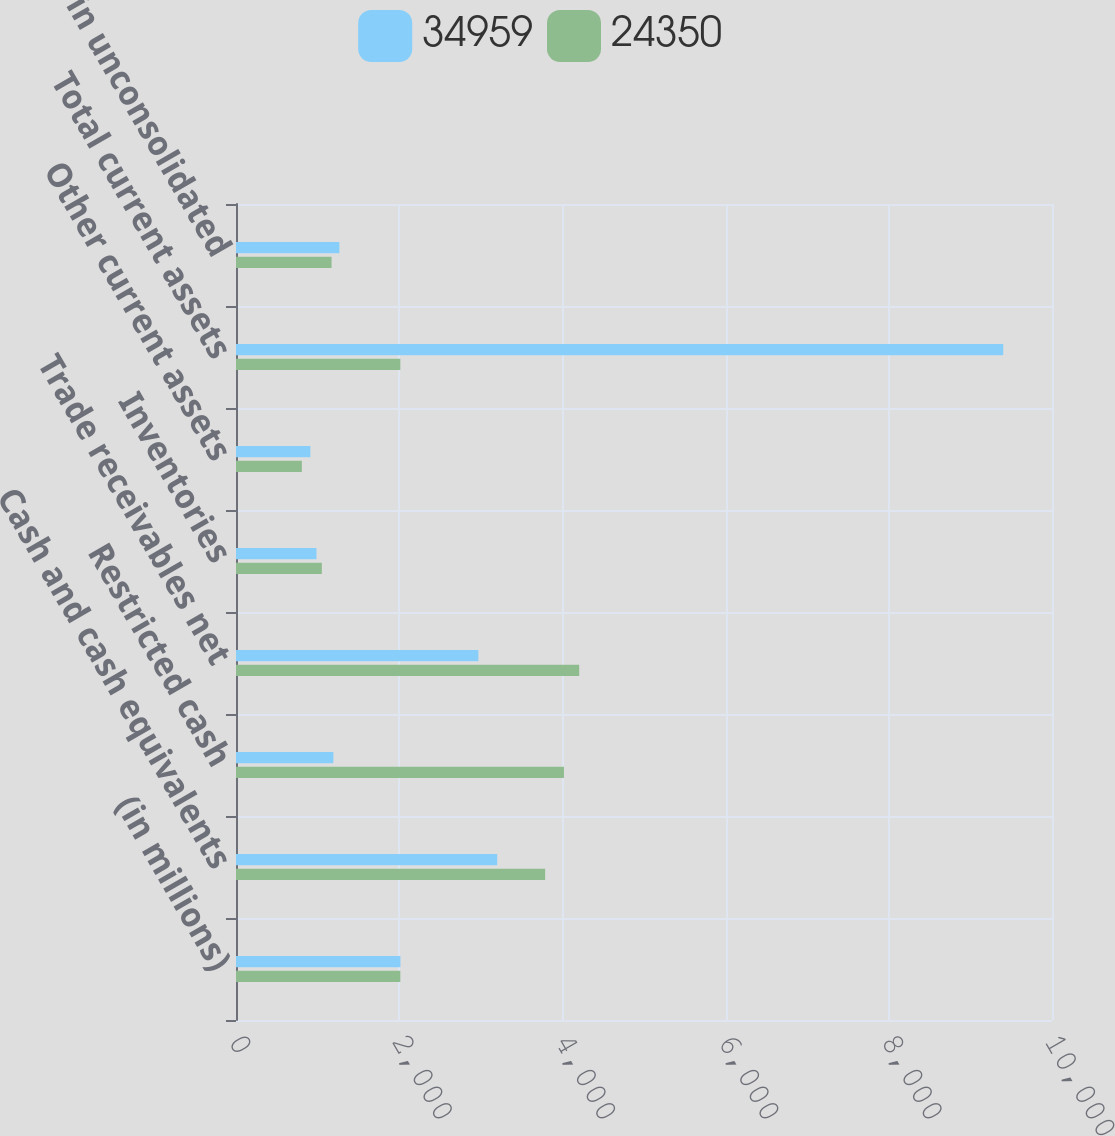Convert chart. <chart><loc_0><loc_0><loc_500><loc_500><stacked_bar_chart><ecel><fcel>(in millions)<fcel>Cash and cash equivalents<fcel>Restricted cash<fcel>Trade receivables net<fcel>Inventories<fcel>Other current assets<fcel>Total current assets<fcel>Investments in unconsolidated<nl><fcel>34959<fcel>2015<fcel>3201<fcel>1193<fcel>2970<fcel>986<fcel>911<fcel>9402<fcel>1267<nl><fcel>24350<fcel>2014<fcel>3789<fcel>4019<fcel>4206<fcel>1052<fcel>807<fcel>2014<fcel>1171<nl></chart> 